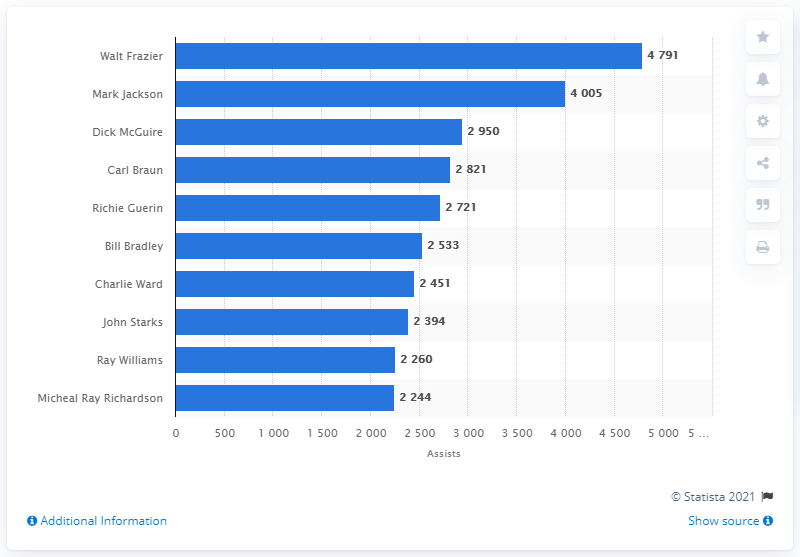Indicate a few pertinent items in this graphic. The career assists leader of the New York Knicks is Walt Frazier. 